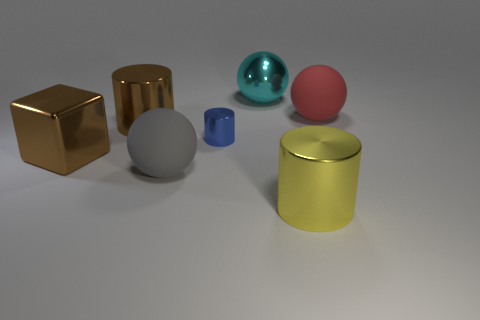Add 2 brown metallic objects. How many objects exist? 9 Subtract all cylinders. How many objects are left? 4 Add 4 large green blocks. How many large green blocks exist? 4 Subtract 0 yellow balls. How many objects are left? 7 Subtract all yellow cylinders. Subtract all rubber spheres. How many objects are left? 4 Add 6 rubber objects. How many rubber objects are left? 8 